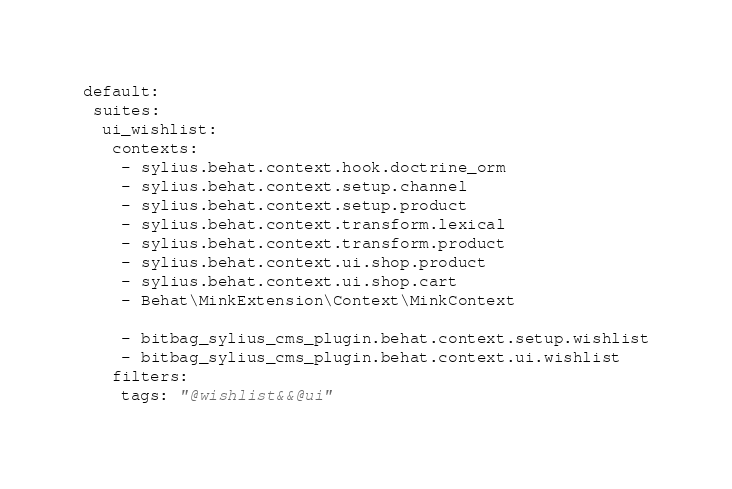Convert code to text. <code><loc_0><loc_0><loc_500><loc_500><_YAML_>default:
 suites:
  ui_wishlist:
   contexts:
    - sylius.behat.context.hook.doctrine_orm
    - sylius.behat.context.setup.channel
    - sylius.behat.context.setup.product
    - sylius.behat.context.transform.lexical
    - sylius.behat.context.transform.product
    - sylius.behat.context.ui.shop.product
    - sylius.behat.context.ui.shop.cart
    - Behat\MinkExtension\Context\MinkContext

    - bitbag_sylius_cms_plugin.behat.context.setup.wishlist
    - bitbag_sylius_cms_plugin.behat.context.ui.wishlist
   filters:
    tags: "@wishlist&&@ui"
</code> 